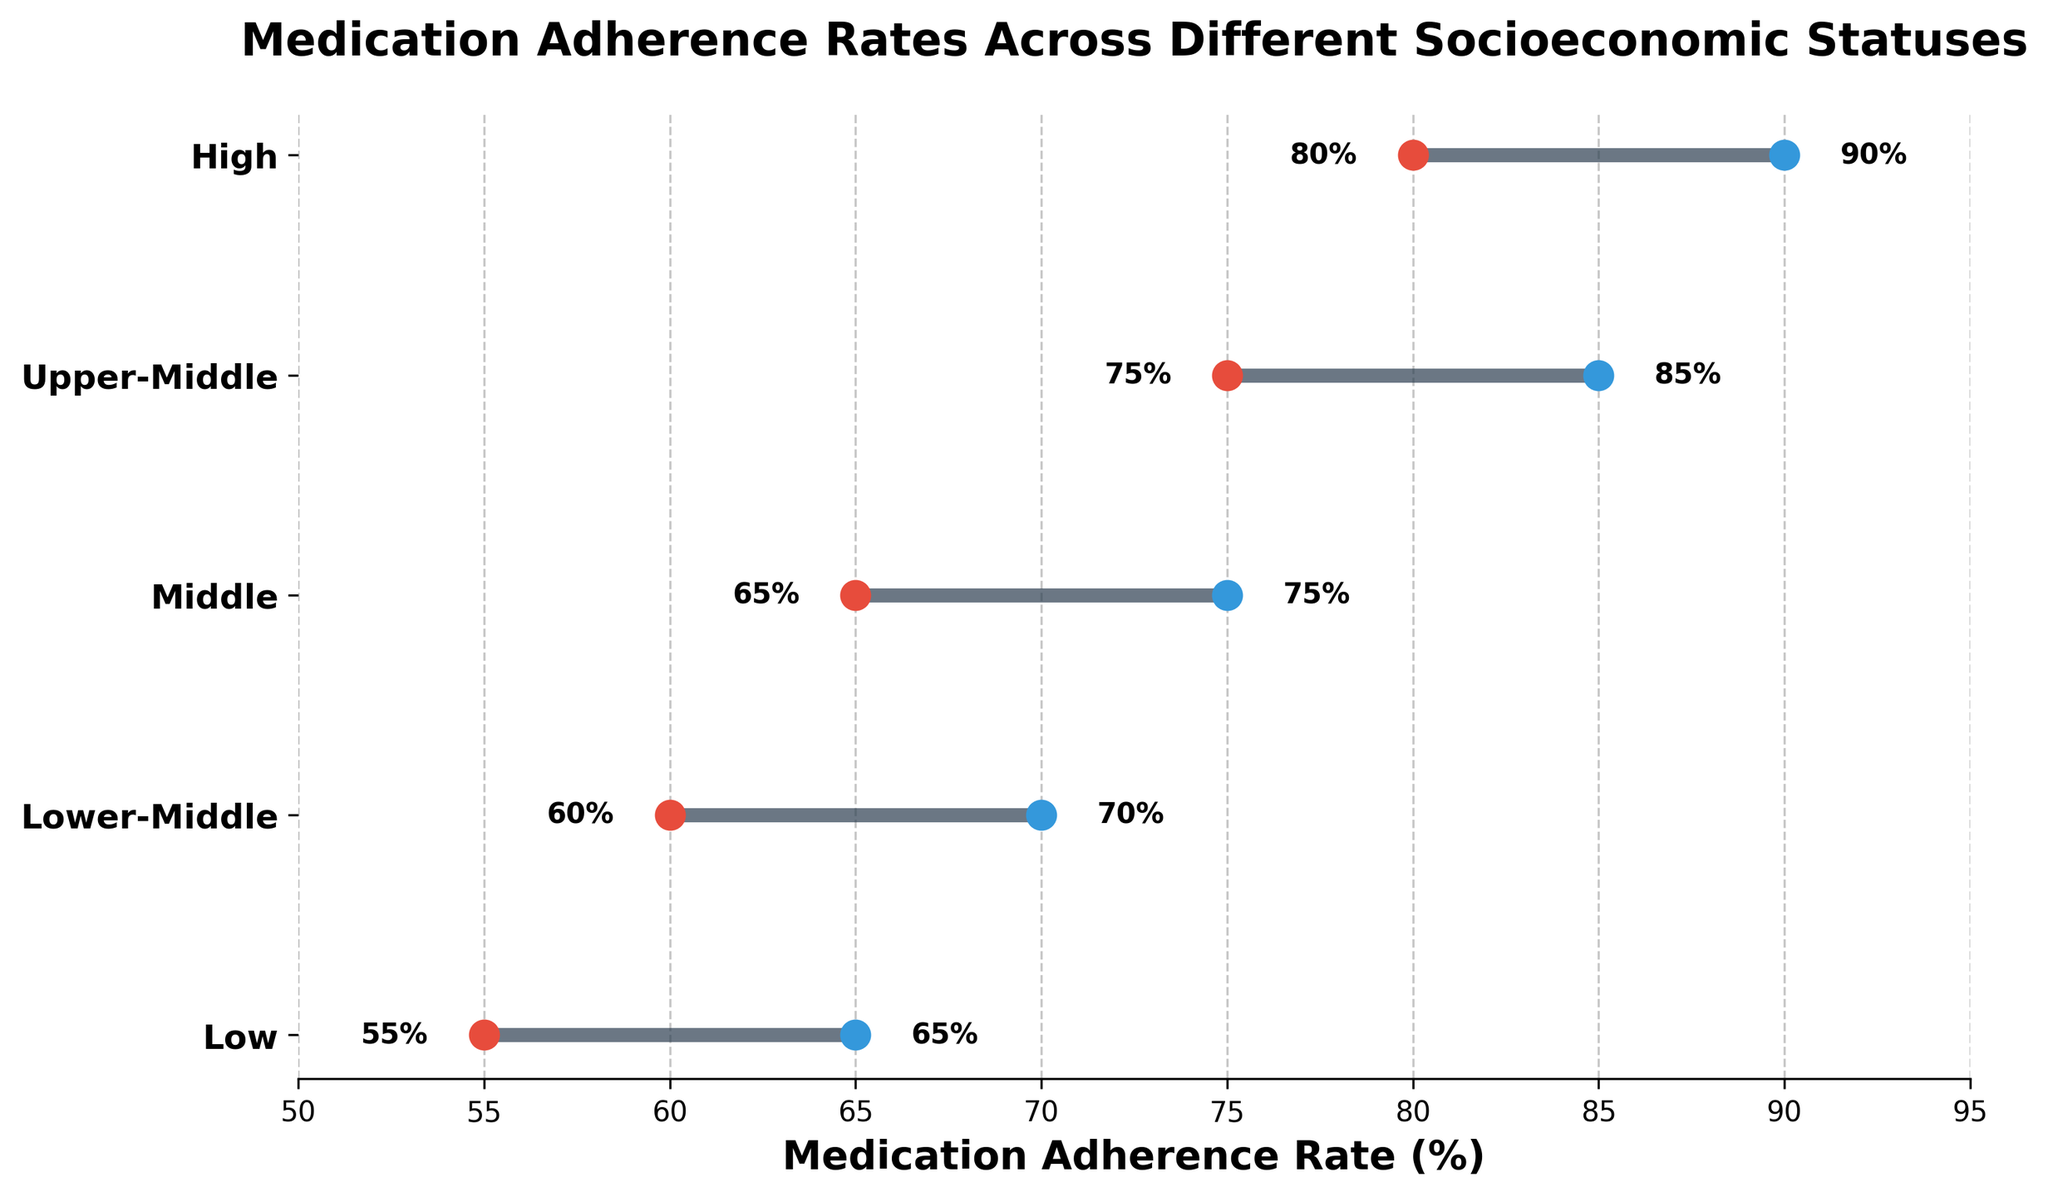What is the title of the plot? The title of the plot is located at the top center of the figure and provides an overview of the data being visualized. In this case, it reads "Medication Adherence Rates Across Different Socioeconomic Statuses."
Answer: Medication Adherence Rates Across Different Socioeconomic Statuses What is the maximum medication adherence rate for the "High" socioeconomic status group? Look at the "High" SES group at the top of the plot and find the upper-bound dot, which indicates the maximum adherence rate.
Answer: 90% What is the range of medication adherence rates for the "Middle" socioeconomic status group? For the "Middle" SES group, identify the lower-bound and upper-bound dots and subtract the lower value from the upper value. Here, the lower value is 65, and the upper value is 75. The range is calculated as 75 - 65.
Answer: 10% Which socioeconomic group has the widest range of medication adherence rates, and what is the range? Examine all the SES groups to determine which has the largest difference between its lower and upper bounds. In the plot, the "Upper-Middle" group spans from 75 to 85, which gives a range of 85 - 75 = 10. Similarly, the "High" group spans from 80 to 90, giving a range of 90 - 80 = 10. Both groups have the widest range.
Answer: Upper-Middle and High, range 10% How does the lower bound of medication adherence rates for the "Upper-Middle" socioeconomic status compare to the upper bound of the "Lower" socioeconomic status? Check the lower bound of the "Upper-Middle" group, which is 75, and compare it to the upper bound of the "Lower" group, which is 65.
Answer: Higher Which socioeconomic status group has the highest minimum medication adherence rate, and what is it? Determine the minimum rates for each SES group by looking at the lower-bound dots, and identify which is the highest. The "High" group has the highest minimum rate of 80.
Answer: High, 80% Calculate the average of the lower bounds of all socioeconomic status groups. Sum the lower bounds of all SES groups (55 + 60 + 65 + 75 + 80) and divide by the number of groups (5). The calculation is (55 + 60 + 65 + 75 + 80)/5.
Answer: 67 Is the upper bound of the "Lower-Middle" socioeconomic status group equal to the lower bound of the "High" socioeconomic status group? Compare the upper bound of "Lower-Middle," which is 70, with the lower bound of "High," which is 80.
Answer: No Which socioeconomic statuses have overlapping ranges of medication adherence rates? Identify SES groups whose lower and upper bounds overlap. The "Lower-Middle" (60-70) overlaps with "Middle" (65-75), and "Middle" (65-75) overlaps with "Upper-Middle" (75-85).
Answer: Lower-Middle & Middle, Middle & Upper-Middle What are the colors used to represent the lower and upper bounds in the plot? The lower bound dots are colored red, and the upper bound dots are colored blue in the plot.
Answer: Red and Blue 